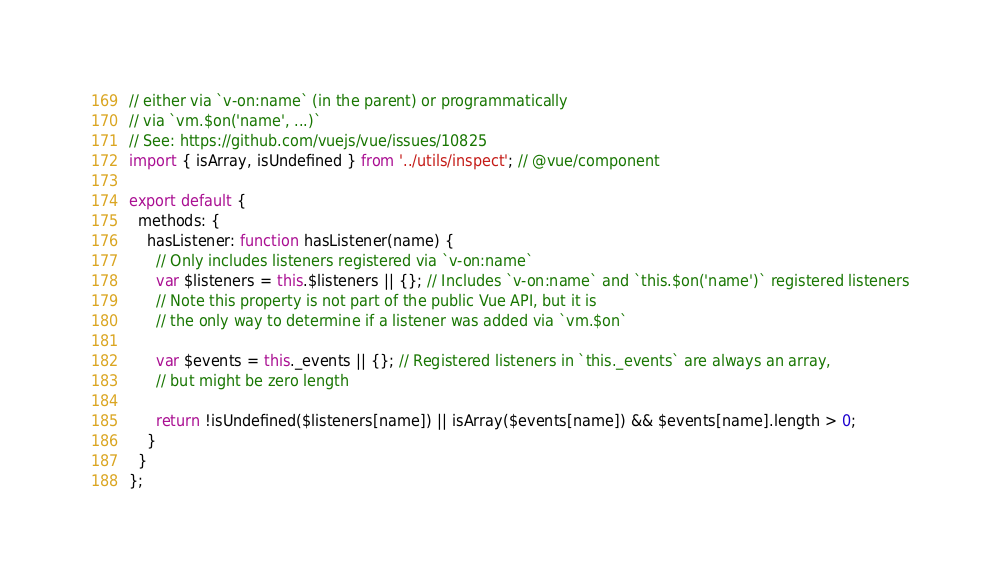Convert code to text. <code><loc_0><loc_0><loc_500><loc_500><_JavaScript_>// either via `v-on:name` (in the parent) or programmatically
// via `vm.$on('name', ...)`
// See: https://github.com/vuejs/vue/issues/10825
import { isArray, isUndefined } from '../utils/inspect'; // @vue/component

export default {
  methods: {
    hasListener: function hasListener(name) {
      // Only includes listeners registered via `v-on:name`
      var $listeners = this.$listeners || {}; // Includes `v-on:name` and `this.$on('name')` registered listeners
      // Note this property is not part of the public Vue API, but it is
      // the only way to determine if a listener was added via `vm.$on`

      var $events = this._events || {}; // Registered listeners in `this._events` are always an array,
      // but might be zero length

      return !isUndefined($listeners[name]) || isArray($events[name]) && $events[name].length > 0;
    }
  }
};</code> 